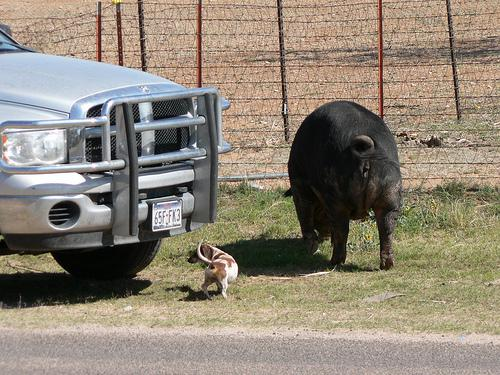Question: where are the animals?
Choices:
A. On grass.
B. On dirt.
C. On gravel.
D. On the shore.
Answer with the letter. Answer: A Question: what color is the truck?
Choices:
A. Red.
B. Black.
C. Gray.
D. Silver.
Answer with the letter. Answer: D Question: why is it light out?
Choices:
A. Flood lights.
B. Stadium lights.
C. Fire.
D. Sunshine.
Answer with the letter. Answer: D Question: what kind of vehicle?
Choices:
A. Mini van.
B. Truck.
C. Van.
D. Sedan.
Answer with the letter. Answer: B 